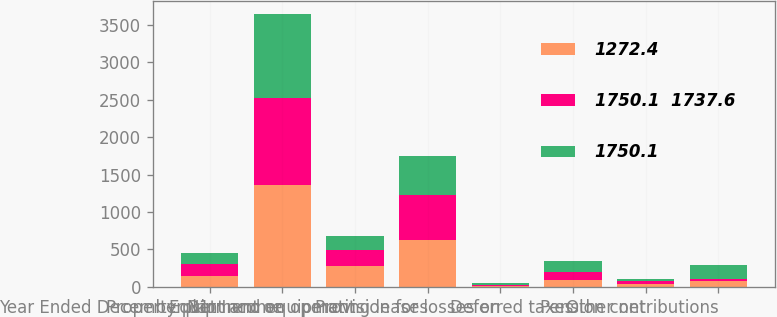Convert chart. <chart><loc_0><loc_0><loc_500><loc_500><stacked_bar_chart><ecel><fcel>Year Ended December 31<fcel>Net Income<fcel>Property plant and equipment<fcel>Equipment on operating leases<fcel>Provision for losses on<fcel>Deferred taxes<fcel>Other net<fcel>Pension contributions<nl><fcel>1272.4<fcel>151.7<fcel>1358.8<fcel>285.2<fcel>632.5<fcel>15.4<fcel>98<fcel>40.4<fcel>81.1<nl><fcel>1750.1  1737.6<fcel>151.7<fcel>1171.3<fcel>210.7<fcel>600<fcel>12.9<fcel>97.3<fcel>36.6<fcel>26.2<nl><fcel>1750.1<fcel>151.7<fcel>1111.6<fcel>188.8<fcel>512.1<fcel>20<fcel>151.7<fcel>34<fcel>190.8<nl></chart> 